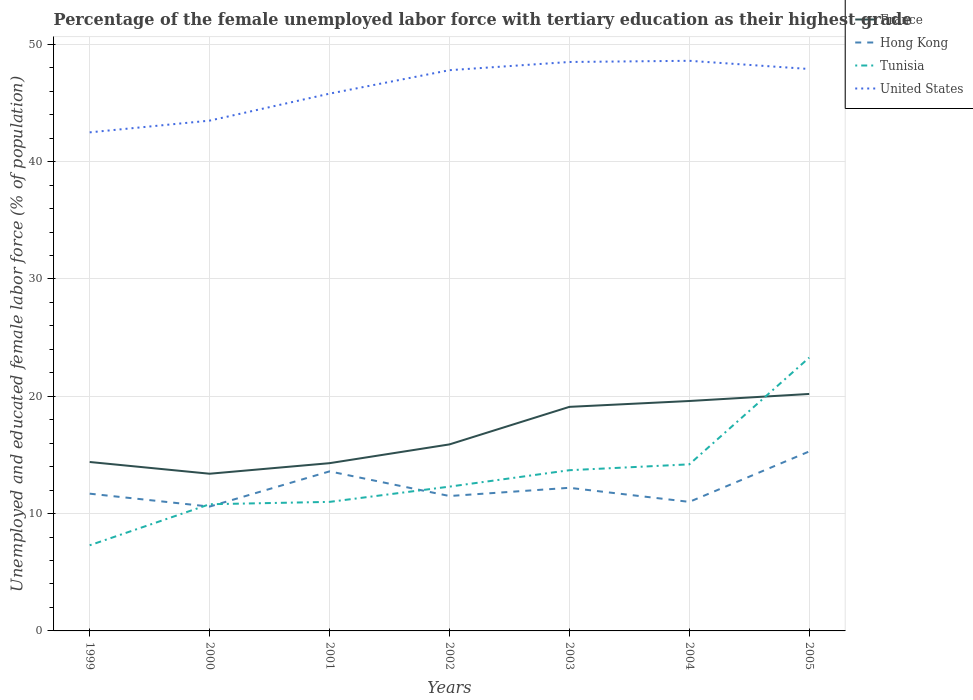How many different coloured lines are there?
Provide a succinct answer. 4. Across all years, what is the maximum percentage of the unemployed female labor force with tertiary education in Tunisia?
Your answer should be compact. 7.3. What is the total percentage of the unemployed female labor force with tertiary education in United States in the graph?
Your response must be concise. -5.1. What is the difference between the highest and the second highest percentage of the unemployed female labor force with tertiary education in Hong Kong?
Give a very brief answer. 4.7. Is the percentage of the unemployed female labor force with tertiary education in Hong Kong strictly greater than the percentage of the unemployed female labor force with tertiary education in Tunisia over the years?
Your answer should be compact. No. How many lines are there?
Offer a very short reply. 4. How many years are there in the graph?
Your response must be concise. 7. Are the values on the major ticks of Y-axis written in scientific E-notation?
Offer a terse response. No. What is the title of the graph?
Your response must be concise. Percentage of the female unemployed labor force with tertiary education as their highest grade. What is the label or title of the X-axis?
Keep it short and to the point. Years. What is the label or title of the Y-axis?
Give a very brief answer. Unemployed and educated female labor force (% of population). What is the Unemployed and educated female labor force (% of population) of France in 1999?
Offer a terse response. 14.4. What is the Unemployed and educated female labor force (% of population) in Hong Kong in 1999?
Your answer should be very brief. 11.7. What is the Unemployed and educated female labor force (% of population) of Tunisia in 1999?
Offer a terse response. 7.3. What is the Unemployed and educated female labor force (% of population) in United States in 1999?
Give a very brief answer. 42.5. What is the Unemployed and educated female labor force (% of population) in France in 2000?
Your response must be concise. 13.4. What is the Unemployed and educated female labor force (% of population) of Hong Kong in 2000?
Keep it short and to the point. 10.6. What is the Unemployed and educated female labor force (% of population) of Tunisia in 2000?
Provide a short and direct response. 10.8. What is the Unemployed and educated female labor force (% of population) in United States in 2000?
Provide a succinct answer. 43.5. What is the Unemployed and educated female labor force (% of population) of France in 2001?
Your response must be concise. 14.3. What is the Unemployed and educated female labor force (% of population) in Hong Kong in 2001?
Give a very brief answer. 13.6. What is the Unemployed and educated female labor force (% of population) in Tunisia in 2001?
Provide a short and direct response. 11. What is the Unemployed and educated female labor force (% of population) in United States in 2001?
Your response must be concise. 45.8. What is the Unemployed and educated female labor force (% of population) in France in 2002?
Offer a very short reply. 15.9. What is the Unemployed and educated female labor force (% of population) of Hong Kong in 2002?
Make the answer very short. 11.5. What is the Unemployed and educated female labor force (% of population) of Tunisia in 2002?
Offer a terse response. 12.3. What is the Unemployed and educated female labor force (% of population) of United States in 2002?
Offer a terse response. 47.8. What is the Unemployed and educated female labor force (% of population) of France in 2003?
Your response must be concise. 19.1. What is the Unemployed and educated female labor force (% of population) in Hong Kong in 2003?
Ensure brevity in your answer.  12.2. What is the Unemployed and educated female labor force (% of population) of Tunisia in 2003?
Keep it short and to the point. 13.7. What is the Unemployed and educated female labor force (% of population) in United States in 2003?
Offer a terse response. 48.5. What is the Unemployed and educated female labor force (% of population) of France in 2004?
Provide a short and direct response. 19.6. What is the Unemployed and educated female labor force (% of population) in Tunisia in 2004?
Provide a succinct answer. 14.2. What is the Unemployed and educated female labor force (% of population) of United States in 2004?
Ensure brevity in your answer.  48.6. What is the Unemployed and educated female labor force (% of population) in France in 2005?
Provide a short and direct response. 20.2. What is the Unemployed and educated female labor force (% of population) of Hong Kong in 2005?
Your answer should be very brief. 15.3. What is the Unemployed and educated female labor force (% of population) of Tunisia in 2005?
Make the answer very short. 23.3. What is the Unemployed and educated female labor force (% of population) in United States in 2005?
Offer a terse response. 47.9. Across all years, what is the maximum Unemployed and educated female labor force (% of population) in France?
Your answer should be compact. 20.2. Across all years, what is the maximum Unemployed and educated female labor force (% of population) of Hong Kong?
Provide a succinct answer. 15.3. Across all years, what is the maximum Unemployed and educated female labor force (% of population) in Tunisia?
Ensure brevity in your answer.  23.3. Across all years, what is the maximum Unemployed and educated female labor force (% of population) in United States?
Your response must be concise. 48.6. Across all years, what is the minimum Unemployed and educated female labor force (% of population) of France?
Your answer should be compact. 13.4. Across all years, what is the minimum Unemployed and educated female labor force (% of population) of Hong Kong?
Offer a very short reply. 10.6. Across all years, what is the minimum Unemployed and educated female labor force (% of population) in Tunisia?
Ensure brevity in your answer.  7.3. Across all years, what is the minimum Unemployed and educated female labor force (% of population) of United States?
Your response must be concise. 42.5. What is the total Unemployed and educated female labor force (% of population) in France in the graph?
Keep it short and to the point. 116.9. What is the total Unemployed and educated female labor force (% of population) of Hong Kong in the graph?
Make the answer very short. 85.9. What is the total Unemployed and educated female labor force (% of population) of Tunisia in the graph?
Make the answer very short. 92.6. What is the total Unemployed and educated female labor force (% of population) in United States in the graph?
Offer a terse response. 324.6. What is the difference between the Unemployed and educated female labor force (% of population) in France in 1999 and that in 2000?
Give a very brief answer. 1. What is the difference between the Unemployed and educated female labor force (% of population) of Hong Kong in 1999 and that in 2000?
Your answer should be very brief. 1.1. What is the difference between the Unemployed and educated female labor force (% of population) in Hong Kong in 1999 and that in 2001?
Offer a very short reply. -1.9. What is the difference between the Unemployed and educated female labor force (% of population) of Hong Kong in 1999 and that in 2002?
Offer a terse response. 0.2. What is the difference between the Unemployed and educated female labor force (% of population) of United States in 1999 and that in 2002?
Your answer should be very brief. -5.3. What is the difference between the Unemployed and educated female labor force (% of population) of France in 1999 and that in 2003?
Provide a succinct answer. -4.7. What is the difference between the Unemployed and educated female labor force (% of population) of United States in 1999 and that in 2003?
Offer a terse response. -6. What is the difference between the Unemployed and educated female labor force (% of population) of Hong Kong in 1999 and that in 2004?
Provide a succinct answer. 0.7. What is the difference between the Unemployed and educated female labor force (% of population) of United States in 1999 and that in 2004?
Your response must be concise. -6.1. What is the difference between the Unemployed and educated female labor force (% of population) of France in 1999 and that in 2005?
Your answer should be very brief. -5.8. What is the difference between the Unemployed and educated female labor force (% of population) in Tunisia in 2000 and that in 2001?
Offer a terse response. -0.2. What is the difference between the Unemployed and educated female labor force (% of population) in Tunisia in 2000 and that in 2002?
Give a very brief answer. -1.5. What is the difference between the Unemployed and educated female labor force (% of population) in United States in 2000 and that in 2002?
Give a very brief answer. -4.3. What is the difference between the Unemployed and educated female labor force (% of population) in France in 2000 and that in 2004?
Ensure brevity in your answer.  -6.2. What is the difference between the Unemployed and educated female labor force (% of population) in Hong Kong in 2000 and that in 2004?
Your answer should be very brief. -0.4. What is the difference between the Unemployed and educated female labor force (% of population) of United States in 2000 and that in 2004?
Your response must be concise. -5.1. What is the difference between the Unemployed and educated female labor force (% of population) of Hong Kong in 2000 and that in 2005?
Offer a terse response. -4.7. What is the difference between the Unemployed and educated female labor force (% of population) in France in 2001 and that in 2002?
Your answer should be compact. -1.6. What is the difference between the Unemployed and educated female labor force (% of population) in Hong Kong in 2001 and that in 2002?
Make the answer very short. 2.1. What is the difference between the Unemployed and educated female labor force (% of population) in Tunisia in 2001 and that in 2002?
Keep it short and to the point. -1.3. What is the difference between the Unemployed and educated female labor force (% of population) in France in 2001 and that in 2003?
Offer a terse response. -4.8. What is the difference between the Unemployed and educated female labor force (% of population) in Hong Kong in 2001 and that in 2003?
Keep it short and to the point. 1.4. What is the difference between the Unemployed and educated female labor force (% of population) of Hong Kong in 2001 and that in 2004?
Provide a succinct answer. 2.6. What is the difference between the Unemployed and educated female labor force (% of population) of Tunisia in 2001 and that in 2005?
Your answer should be very brief. -12.3. What is the difference between the Unemployed and educated female labor force (% of population) of United States in 2001 and that in 2005?
Your response must be concise. -2.1. What is the difference between the Unemployed and educated female labor force (% of population) of France in 2002 and that in 2003?
Ensure brevity in your answer.  -3.2. What is the difference between the Unemployed and educated female labor force (% of population) of Tunisia in 2002 and that in 2003?
Offer a terse response. -1.4. What is the difference between the Unemployed and educated female labor force (% of population) of United States in 2002 and that in 2003?
Keep it short and to the point. -0.7. What is the difference between the Unemployed and educated female labor force (% of population) of France in 2002 and that in 2004?
Your answer should be compact. -3.7. What is the difference between the Unemployed and educated female labor force (% of population) in Hong Kong in 2002 and that in 2004?
Offer a terse response. 0.5. What is the difference between the Unemployed and educated female labor force (% of population) in Tunisia in 2002 and that in 2004?
Your response must be concise. -1.9. What is the difference between the Unemployed and educated female labor force (% of population) in Tunisia in 2002 and that in 2005?
Give a very brief answer. -11. What is the difference between the Unemployed and educated female labor force (% of population) in France in 2003 and that in 2004?
Make the answer very short. -0.5. What is the difference between the Unemployed and educated female labor force (% of population) in Hong Kong in 2003 and that in 2004?
Offer a terse response. 1.2. What is the difference between the Unemployed and educated female labor force (% of population) of Tunisia in 2003 and that in 2004?
Give a very brief answer. -0.5. What is the difference between the Unemployed and educated female labor force (% of population) of France in 2003 and that in 2005?
Make the answer very short. -1.1. What is the difference between the Unemployed and educated female labor force (% of population) of Tunisia in 2003 and that in 2005?
Make the answer very short. -9.6. What is the difference between the Unemployed and educated female labor force (% of population) in France in 2004 and that in 2005?
Your response must be concise. -0.6. What is the difference between the Unemployed and educated female labor force (% of population) of France in 1999 and the Unemployed and educated female labor force (% of population) of United States in 2000?
Give a very brief answer. -29.1. What is the difference between the Unemployed and educated female labor force (% of population) in Hong Kong in 1999 and the Unemployed and educated female labor force (% of population) in Tunisia in 2000?
Your answer should be compact. 0.9. What is the difference between the Unemployed and educated female labor force (% of population) in Hong Kong in 1999 and the Unemployed and educated female labor force (% of population) in United States in 2000?
Your answer should be very brief. -31.8. What is the difference between the Unemployed and educated female labor force (% of population) of Tunisia in 1999 and the Unemployed and educated female labor force (% of population) of United States in 2000?
Provide a succinct answer. -36.2. What is the difference between the Unemployed and educated female labor force (% of population) of France in 1999 and the Unemployed and educated female labor force (% of population) of Hong Kong in 2001?
Your answer should be compact. 0.8. What is the difference between the Unemployed and educated female labor force (% of population) of France in 1999 and the Unemployed and educated female labor force (% of population) of United States in 2001?
Your response must be concise. -31.4. What is the difference between the Unemployed and educated female labor force (% of population) in Hong Kong in 1999 and the Unemployed and educated female labor force (% of population) in Tunisia in 2001?
Offer a very short reply. 0.7. What is the difference between the Unemployed and educated female labor force (% of population) in Hong Kong in 1999 and the Unemployed and educated female labor force (% of population) in United States in 2001?
Offer a terse response. -34.1. What is the difference between the Unemployed and educated female labor force (% of population) in Tunisia in 1999 and the Unemployed and educated female labor force (% of population) in United States in 2001?
Ensure brevity in your answer.  -38.5. What is the difference between the Unemployed and educated female labor force (% of population) of France in 1999 and the Unemployed and educated female labor force (% of population) of Hong Kong in 2002?
Your answer should be compact. 2.9. What is the difference between the Unemployed and educated female labor force (% of population) of France in 1999 and the Unemployed and educated female labor force (% of population) of Tunisia in 2002?
Make the answer very short. 2.1. What is the difference between the Unemployed and educated female labor force (% of population) in France in 1999 and the Unemployed and educated female labor force (% of population) in United States in 2002?
Offer a terse response. -33.4. What is the difference between the Unemployed and educated female labor force (% of population) of Hong Kong in 1999 and the Unemployed and educated female labor force (% of population) of Tunisia in 2002?
Offer a terse response. -0.6. What is the difference between the Unemployed and educated female labor force (% of population) in Hong Kong in 1999 and the Unemployed and educated female labor force (% of population) in United States in 2002?
Ensure brevity in your answer.  -36.1. What is the difference between the Unemployed and educated female labor force (% of population) of Tunisia in 1999 and the Unemployed and educated female labor force (% of population) of United States in 2002?
Provide a short and direct response. -40.5. What is the difference between the Unemployed and educated female labor force (% of population) of France in 1999 and the Unemployed and educated female labor force (% of population) of Hong Kong in 2003?
Your answer should be compact. 2.2. What is the difference between the Unemployed and educated female labor force (% of population) of France in 1999 and the Unemployed and educated female labor force (% of population) of United States in 2003?
Offer a terse response. -34.1. What is the difference between the Unemployed and educated female labor force (% of population) of Hong Kong in 1999 and the Unemployed and educated female labor force (% of population) of Tunisia in 2003?
Give a very brief answer. -2. What is the difference between the Unemployed and educated female labor force (% of population) of Hong Kong in 1999 and the Unemployed and educated female labor force (% of population) of United States in 2003?
Offer a terse response. -36.8. What is the difference between the Unemployed and educated female labor force (% of population) in Tunisia in 1999 and the Unemployed and educated female labor force (% of population) in United States in 2003?
Offer a very short reply. -41.2. What is the difference between the Unemployed and educated female labor force (% of population) of France in 1999 and the Unemployed and educated female labor force (% of population) of Tunisia in 2004?
Give a very brief answer. 0.2. What is the difference between the Unemployed and educated female labor force (% of population) of France in 1999 and the Unemployed and educated female labor force (% of population) of United States in 2004?
Make the answer very short. -34.2. What is the difference between the Unemployed and educated female labor force (% of population) of Hong Kong in 1999 and the Unemployed and educated female labor force (% of population) of United States in 2004?
Provide a short and direct response. -36.9. What is the difference between the Unemployed and educated female labor force (% of population) of Tunisia in 1999 and the Unemployed and educated female labor force (% of population) of United States in 2004?
Your response must be concise. -41.3. What is the difference between the Unemployed and educated female labor force (% of population) of France in 1999 and the Unemployed and educated female labor force (% of population) of Hong Kong in 2005?
Offer a very short reply. -0.9. What is the difference between the Unemployed and educated female labor force (% of population) in France in 1999 and the Unemployed and educated female labor force (% of population) in United States in 2005?
Keep it short and to the point. -33.5. What is the difference between the Unemployed and educated female labor force (% of population) of Hong Kong in 1999 and the Unemployed and educated female labor force (% of population) of Tunisia in 2005?
Your answer should be compact. -11.6. What is the difference between the Unemployed and educated female labor force (% of population) of Hong Kong in 1999 and the Unemployed and educated female labor force (% of population) of United States in 2005?
Offer a terse response. -36.2. What is the difference between the Unemployed and educated female labor force (% of population) of Tunisia in 1999 and the Unemployed and educated female labor force (% of population) of United States in 2005?
Offer a terse response. -40.6. What is the difference between the Unemployed and educated female labor force (% of population) of France in 2000 and the Unemployed and educated female labor force (% of population) of United States in 2001?
Keep it short and to the point. -32.4. What is the difference between the Unemployed and educated female labor force (% of population) of Hong Kong in 2000 and the Unemployed and educated female labor force (% of population) of Tunisia in 2001?
Provide a short and direct response. -0.4. What is the difference between the Unemployed and educated female labor force (% of population) in Hong Kong in 2000 and the Unemployed and educated female labor force (% of population) in United States in 2001?
Ensure brevity in your answer.  -35.2. What is the difference between the Unemployed and educated female labor force (% of population) of Tunisia in 2000 and the Unemployed and educated female labor force (% of population) of United States in 2001?
Give a very brief answer. -35. What is the difference between the Unemployed and educated female labor force (% of population) in France in 2000 and the Unemployed and educated female labor force (% of population) in Hong Kong in 2002?
Offer a terse response. 1.9. What is the difference between the Unemployed and educated female labor force (% of population) in France in 2000 and the Unemployed and educated female labor force (% of population) in United States in 2002?
Your response must be concise. -34.4. What is the difference between the Unemployed and educated female labor force (% of population) in Hong Kong in 2000 and the Unemployed and educated female labor force (% of population) in United States in 2002?
Your response must be concise. -37.2. What is the difference between the Unemployed and educated female labor force (% of population) of Tunisia in 2000 and the Unemployed and educated female labor force (% of population) of United States in 2002?
Your answer should be very brief. -37. What is the difference between the Unemployed and educated female labor force (% of population) of France in 2000 and the Unemployed and educated female labor force (% of population) of Hong Kong in 2003?
Offer a very short reply. 1.2. What is the difference between the Unemployed and educated female labor force (% of population) in France in 2000 and the Unemployed and educated female labor force (% of population) in Tunisia in 2003?
Offer a terse response. -0.3. What is the difference between the Unemployed and educated female labor force (% of population) in France in 2000 and the Unemployed and educated female labor force (% of population) in United States in 2003?
Keep it short and to the point. -35.1. What is the difference between the Unemployed and educated female labor force (% of population) of Hong Kong in 2000 and the Unemployed and educated female labor force (% of population) of Tunisia in 2003?
Offer a terse response. -3.1. What is the difference between the Unemployed and educated female labor force (% of population) of Hong Kong in 2000 and the Unemployed and educated female labor force (% of population) of United States in 2003?
Your answer should be very brief. -37.9. What is the difference between the Unemployed and educated female labor force (% of population) in Tunisia in 2000 and the Unemployed and educated female labor force (% of population) in United States in 2003?
Offer a terse response. -37.7. What is the difference between the Unemployed and educated female labor force (% of population) of France in 2000 and the Unemployed and educated female labor force (% of population) of Hong Kong in 2004?
Ensure brevity in your answer.  2.4. What is the difference between the Unemployed and educated female labor force (% of population) in France in 2000 and the Unemployed and educated female labor force (% of population) in Tunisia in 2004?
Offer a very short reply. -0.8. What is the difference between the Unemployed and educated female labor force (% of population) of France in 2000 and the Unemployed and educated female labor force (% of population) of United States in 2004?
Your response must be concise. -35.2. What is the difference between the Unemployed and educated female labor force (% of population) of Hong Kong in 2000 and the Unemployed and educated female labor force (% of population) of Tunisia in 2004?
Provide a succinct answer. -3.6. What is the difference between the Unemployed and educated female labor force (% of population) in Hong Kong in 2000 and the Unemployed and educated female labor force (% of population) in United States in 2004?
Give a very brief answer. -38. What is the difference between the Unemployed and educated female labor force (% of population) of Tunisia in 2000 and the Unemployed and educated female labor force (% of population) of United States in 2004?
Provide a short and direct response. -37.8. What is the difference between the Unemployed and educated female labor force (% of population) in France in 2000 and the Unemployed and educated female labor force (% of population) in United States in 2005?
Make the answer very short. -34.5. What is the difference between the Unemployed and educated female labor force (% of population) in Hong Kong in 2000 and the Unemployed and educated female labor force (% of population) in Tunisia in 2005?
Offer a very short reply. -12.7. What is the difference between the Unemployed and educated female labor force (% of population) of Hong Kong in 2000 and the Unemployed and educated female labor force (% of population) of United States in 2005?
Offer a very short reply. -37.3. What is the difference between the Unemployed and educated female labor force (% of population) in Tunisia in 2000 and the Unemployed and educated female labor force (% of population) in United States in 2005?
Provide a short and direct response. -37.1. What is the difference between the Unemployed and educated female labor force (% of population) in France in 2001 and the Unemployed and educated female labor force (% of population) in Tunisia in 2002?
Your response must be concise. 2. What is the difference between the Unemployed and educated female labor force (% of population) of France in 2001 and the Unemployed and educated female labor force (% of population) of United States in 2002?
Offer a terse response. -33.5. What is the difference between the Unemployed and educated female labor force (% of population) of Hong Kong in 2001 and the Unemployed and educated female labor force (% of population) of Tunisia in 2002?
Offer a terse response. 1.3. What is the difference between the Unemployed and educated female labor force (% of population) in Hong Kong in 2001 and the Unemployed and educated female labor force (% of population) in United States in 2002?
Give a very brief answer. -34.2. What is the difference between the Unemployed and educated female labor force (% of population) in Tunisia in 2001 and the Unemployed and educated female labor force (% of population) in United States in 2002?
Your answer should be compact. -36.8. What is the difference between the Unemployed and educated female labor force (% of population) in France in 2001 and the Unemployed and educated female labor force (% of population) in Hong Kong in 2003?
Your answer should be very brief. 2.1. What is the difference between the Unemployed and educated female labor force (% of population) in France in 2001 and the Unemployed and educated female labor force (% of population) in Tunisia in 2003?
Offer a terse response. 0.6. What is the difference between the Unemployed and educated female labor force (% of population) of France in 2001 and the Unemployed and educated female labor force (% of population) of United States in 2003?
Offer a terse response. -34.2. What is the difference between the Unemployed and educated female labor force (% of population) of Hong Kong in 2001 and the Unemployed and educated female labor force (% of population) of United States in 2003?
Make the answer very short. -34.9. What is the difference between the Unemployed and educated female labor force (% of population) in Tunisia in 2001 and the Unemployed and educated female labor force (% of population) in United States in 2003?
Your response must be concise. -37.5. What is the difference between the Unemployed and educated female labor force (% of population) in France in 2001 and the Unemployed and educated female labor force (% of population) in Hong Kong in 2004?
Give a very brief answer. 3.3. What is the difference between the Unemployed and educated female labor force (% of population) of France in 2001 and the Unemployed and educated female labor force (% of population) of United States in 2004?
Provide a succinct answer. -34.3. What is the difference between the Unemployed and educated female labor force (% of population) of Hong Kong in 2001 and the Unemployed and educated female labor force (% of population) of United States in 2004?
Your answer should be compact. -35. What is the difference between the Unemployed and educated female labor force (% of population) of Tunisia in 2001 and the Unemployed and educated female labor force (% of population) of United States in 2004?
Provide a succinct answer. -37.6. What is the difference between the Unemployed and educated female labor force (% of population) of France in 2001 and the Unemployed and educated female labor force (% of population) of Hong Kong in 2005?
Provide a short and direct response. -1. What is the difference between the Unemployed and educated female labor force (% of population) of France in 2001 and the Unemployed and educated female labor force (% of population) of United States in 2005?
Offer a very short reply. -33.6. What is the difference between the Unemployed and educated female labor force (% of population) in Hong Kong in 2001 and the Unemployed and educated female labor force (% of population) in Tunisia in 2005?
Your answer should be very brief. -9.7. What is the difference between the Unemployed and educated female labor force (% of population) in Hong Kong in 2001 and the Unemployed and educated female labor force (% of population) in United States in 2005?
Keep it short and to the point. -34.3. What is the difference between the Unemployed and educated female labor force (% of population) of Tunisia in 2001 and the Unemployed and educated female labor force (% of population) of United States in 2005?
Make the answer very short. -36.9. What is the difference between the Unemployed and educated female labor force (% of population) in France in 2002 and the Unemployed and educated female labor force (% of population) in Hong Kong in 2003?
Offer a very short reply. 3.7. What is the difference between the Unemployed and educated female labor force (% of population) in France in 2002 and the Unemployed and educated female labor force (% of population) in United States in 2003?
Give a very brief answer. -32.6. What is the difference between the Unemployed and educated female labor force (% of population) of Hong Kong in 2002 and the Unemployed and educated female labor force (% of population) of Tunisia in 2003?
Keep it short and to the point. -2.2. What is the difference between the Unemployed and educated female labor force (% of population) of Hong Kong in 2002 and the Unemployed and educated female labor force (% of population) of United States in 2003?
Make the answer very short. -37. What is the difference between the Unemployed and educated female labor force (% of population) in Tunisia in 2002 and the Unemployed and educated female labor force (% of population) in United States in 2003?
Provide a short and direct response. -36.2. What is the difference between the Unemployed and educated female labor force (% of population) in France in 2002 and the Unemployed and educated female labor force (% of population) in Hong Kong in 2004?
Keep it short and to the point. 4.9. What is the difference between the Unemployed and educated female labor force (% of population) of France in 2002 and the Unemployed and educated female labor force (% of population) of United States in 2004?
Offer a very short reply. -32.7. What is the difference between the Unemployed and educated female labor force (% of population) in Hong Kong in 2002 and the Unemployed and educated female labor force (% of population) in Tunisia in 2004?
Keep it short and to the point. -2.7. What is the difference between the Unemployed and educated female labor force (% of population) in Hong Kong in 2002 and the Unemployed and educated female labor force (% of population) in United States in 2004?
Your answer should be compact. -37.1. What is the difference between the Unemployed and educated female labor force (% of population) of Tunisia in 2002 and the Unemployed and educated female labor force (% of population) of United States in 2004?
Your response must be concise. -36.3. What is the difference between the Unemployed and educated female labor force (% of population) of France in 2002 and the Unemployed and educated female labor force (% of population) of Tunisia in 2005?
Your answer should be compact. -7.4. What is the difference between the Unemployed and educated female labor force (% of population) of France in 2002 and the Unemployed and educated female labor force (% of population) of United States in 2005?
Give a very brief answer. -32. What is the difference between the Unemployed and educated female labor force (% of population) of Hong Kong in 2002 and the Unemployed and educated female labor force (% of population) of Tunisia in 2005?
Your answer should be very brief. -11.8. What is the difference between the Unemployed and educated female labor force (% of population) in Hong Kong in 2002 and the Unemployed and educated female labor force (% of population) in United States in 2005?
Give a very brief answer. -36.4. What is the difference between the Unemployed and educated female labor force (% of population) in Tunisia in 2002 and the Unemployed and educated female labor force (% of population) in United States in 2005?
Offer a terse response. -35.6. What is the difference between the Unemployed and educated female labor force (% of population) in France in 2003 and the Unemployed and educated female labor force (% of population) in United States in 2004?
Give a very brief answer. -29.5. What is the difference between the Unemployed and educated female labor force (% of population) in Hong Kong in 2003 and the Unemployed and educated female labor force (% of population) in United States in 2004?
Your response must be concise. -36.4. What is the difference between the Unemployed and educated female labor force (% of population) in Tunisia in 2003 and the Unemployed and educated female labor force (% of population) in United States in 2004?
Ensure brevity in your answer.  -34.9. What is the difference between the Unemployed and educated female labor force (% of population) of France in 2003 and the Unemployed and educated female labor force (% of population) of Hong Kong in 2005?
Provide a succinct answer. 3.8. What is the difference between the Unemployed and educated female labor force (% of population) in France in 2003 and the Unemployed and educated female labor force (% of population) in Tunisia in 2005?
Your answer should be very brief. -4.2. What is the difference between the Unemployed and educated female labor force (% of population) of France in 2003 and the Unemployed and educated female labor force (% of population) of United States in 2005?
Provide a succinct answer. -28.8. What is the difference between the Unemployed and educated female labor force (% of population) of Hong Kong in 2003 and the Unemployed and educated female labor force (% of population) of Tunisia in 2005?
Your answer should be compact. -11.1. What is the difference between the Unemployed and educated female labor force (% of population) of Hong Kong in 2003 and the Unemployed and educated female labor force (% of population) of United States in 2005?
Ensure brevity in your answer.  -35.7. What is the difference between the Unemployed and educated female labor force (% of population) of Tunisia in 2003 and the Unemployed and educated female labor force (% of population) of United States in 2005?
Offer a very short reply. -34.2. What is the difference between the Unemployed and educated female labor force (% of population) in France in 2004 and the Unemployed and educated female labor force (% of population) in United States in 2005?
Provide a short and direct response. -28.3. What is the difference between the Unemployed and educated female labor force (% of population) in Hong Kong in 2004 and the Unemployed and educated female labor force (% of population) in Tunisia in 2005?
Make the answer very short. -12.3. What is the difference between the Unemployed and educated female labor force (% of population) of Hong Kong in 2004 and the Unemployed and educated female labor force (% of population) of United States in 2005?
Your answer should be very brief. -36.9. What is the difference between the Unemployed and educated female labor force (% of population) in Tunisia in 2004 and the Unemployed and educated female labor force (% of population) in United States in 2005?
Provide a succinct answer. -33.7. What is the average Unemployed and educated female labor force (% of population) in Hong Kong per year?
Offer a terse response. 12.27. What is the average Unemployed and educated female labor force (% of population) of Tunisia per year?
Your answer should be very brief. 13.23. What is the average Unemployed and educated female labor force (% of population) in United States per year?
Provide a short and direct response. 46.37. In the year 1999, what is the difference between the Unemployed and educated female labor force (% of population) of France and Unemployed and educated female labor force (% of population) of United States?
Your answer should be compact. -28.1. In the year 1999, what is the difference between the Unemployed and educated female labor force (% of population) of Hong Kong and Unemployed and educated female labor force (% of population) of Tunisia?
Offer a very short reply. 4.4. In the year 1999, what is the difference between the Unemployed and educated female labor force (% of population) in Hong Kong and Unemployed and educated female labor force (% of population) in United States?
Keep it short and to the point. -30.8. In the year 1999, what is the difference between the Unemployed and educated female labor force (% of population) of Tunisia and Unemployed and educated female labor force (% of population) of United States?
Make the answer very short. -35.2. In the year 2000, what is the difference between the Unemployed and educated female labor force (% of population) of France and Unemployed and educated female labor force (% of population) of United States?
Your answer should be very brief. -30.1. In the year 2000, what is the difference between the Unemployed and educated female labor force (% of population) in Hong Kong and Unemployed and educated female labor force (% of population) in Tunisia?
Ensure brevity in your answer.  -0.2. In the year 2000, what is the difference between the Unemployed and educated female labor force (% of population) of Hong Kong and Unemployed and educated female labor force (% of population) of United States?
Keep it short and to the point. -32.9. In the year 2000, what is the difference between the Unemployed and educated female labor force (% of population) of Tunisia and Unemployed and educated female labor force (% of population) of United States?
Offer a terse response. -32.7. In the year 2001, what is the difference between the Unemployed and educated female labor force (% of population) in France and Unemployed and educated female labor force (% of population) in Tunisia?
Give a very brief answer. 3.3. In the year 2001, what is the difference between the Unemployed and educated female labor force (% of population) of France and Unemployed and educated female labor force (% of population) of United States?
Keep it short and to the point. -31.5. In the year 2001, what is the difference between the Unemployed and educated female labor force (% of population) in Hong Kong and Unemployed and educated female labor force (% of population) in United States?
Offer a very short reply. -32.2. In the year 2001, what is the difference between the Unemployed and educated female labor force (% of population) in Tunisia and Unemployed and educated female labor force (% of population) in United States?
Your response must be concise. -34.8. In the year 2002, what is the difference between the Unemployed and educated female labor force (% of population) in France and Unemployed and educated female labor force (% of population) in Hong Kong?
Give a very brief answer. 4.4. In the year 2002, what is the difference between the Unemployed and educated female labor force (% of population) of France and Unemployed and educated female labor force (% of population) of Tunisia?
Give a very brief answer. 3.6. In the year 2002, what is the difference between the Unemployed and educated female labor force (% of population) of France and Unemployed and educated female labor force (% of population) of United States?
Offer a terse response. -31.9. In the year 2002, what is the difference between the Unemployed and educated female labor force (% of population) of Hong Kong and Unemployed and educated female labor force (% of population) of Tunisia?
Keep it short and to the point. -0.8. In the year 2002, what is the difference between the Unemployed and educated female labor force (% of population) of Hong Kong and Unemployed and educated female labor force (% of population) of United States?
Make the answer very short. -36.3. In the year 2002, what is the difference between the Unemployed and educated female labor force (% of population) in Tunisia and Unemployed and educated female labor force (% of population) in United States?
Provide a succinct answer. -35.5. In the year 2003, what is the difference between the Unemployed and educated female labor force (% of population) in France and Unemployed and educated female labor force (% of population) in Tunisia?
Provide a succinct answer. 5.4. In the year 2003, what is the difference between the Unemployed and educated female labor force (% of population) of France and Unemployed and educated female labor force (% of population) of United States?
Give a very brief answer. -29.4. In the year 2003, what is the difference between the Unemployed and educated female labor force (% of population) in Hong Kong and Unemployed and educated female labor force (% of population) in Tunisia?
Provide a short and direct response. -1.5. In the year 2003, what is the difference between the Unemployed and educated female labor force (% of population) of Hong Kong and Unemployed and educated female labor force (% of population) of United States?
Your response must be concise. -36.3. In the year 2003, what is the difference between the Unemployed and educated female labor force (% of population) of Tunisia and Unemployed and educated female labor force (% of population) of United States?
Give a very brief answer. -34.8. In the year 2004, what is the difference between the Unemployed and educated female labor force (% of population) in France and Unemployed and educated female labor force (% of population) in Hong Kong?
Offer a very short reply. 8.6. In the year 2004, what is the difference between the Unemployed and educated female labor force (% of population) of Hong Kong and Unemployed and educated female labor force (% of population) of United States?
Your answer should be very brief. -37.6. In the year 2004, what is the difference between the Unemployed and educated female labor force (% of population) in Tunisia and Unemployed and educated female labor force (% of population) in United States?
Offer a terse response. -34.4. In the year 2005, what is the difference between the Unemployed and educated female labor force (% of population) in France and Unemployed and educated female labor force (% of population) in United States?
Keep it short and to the point. -27.7. In the year 2005, what is the difference between the Unemployed and educated female labor force (% of population) in Hong Kong and Unemployed and educated female labor force (% of population) in United States?
Provide a succinct answer. -32.6. In the year 2005, what is the difference between the Unemployed and educated female labor force (% of population) of Tunisia and Unemployed and educated female labor force (% of population) of United States?
Provide a succinct answer. -24.6. What is the ratio of the Unemployed and educated female labor force (% of population) in France in 1999 to that in 2000?
Your answer should be compact. 1.07. What is the ratio of the Unemployed and educated female labor force (% of population) of Hong Kong in 1999 to that in 2000?
Your answer should be very brief. 1.1. What is the ratio of the Unemployed and educated female labor force (% of population) in Tunisia in 1999 to that in 2000?
Offer a very short reply. 0.68. What is the ratio of the Unemployed and educated female labor force (% of population) in Hong Kong in 1999 to that in 2001?
Keep it short and to the point. 0.86. What is the ratio of the Unemployed and educated female labor force (% of population) of Tunisia in 1999 to that in 2001?
Offer a very short reply. 0.66. What is the ratio of the Unemployed and educated female labor force (% of population) of United States in 1999 to that in 2001?
Give a very brief answer. 0.93. What is the ratio of the Unemployed and educated female labor force (% of population) of France in 1999 to that in 2002?
Make the answer very short. 0.91. What is the ratio of the Unemployed and educated female labor force (% of population) of Hong Kong in 1999 to that in 2002?
Offer a terse response. 1.02. What is the ratio of the Unemployed and educated female labor force (% of population) of Tunisia in 1999 to that in 2002?
Give a very brief answer. 0.59. What is the ratio of the Unemployed and educated female labor force (% of population) in United States in 1999 to that in 2002?
Give a very brief answer. 0.89. What is the ratio of the Unemployed and educated female labor force (% of population) in France in 1999 to that in 2003?
Offer a terse response. 0.75. What is the ratio of the Unemployed and educated female labor force (% of population) of Hong Kong in 1999 to that in 2003?
Your answer should be very brief. 0.96. What is the ratio of the Unemployed and educated female labor force (% of population) in Tunisia in 1999 to that in 2003?
Offer a terse response. 0.53. What is the ratio of the Unemployed and educated female labor force (% of population) of United States in 1999 to that in 2003?
Offer a terse response. 0.88. What is the ratio of the Unemployed and educated female labor force (% of population) of France in 1999 to that in 2004?
Give a very brief answer. 0.73. What is the ratio of the Unemployed and educated female labor force (% of population) in Hong Kong in 1999 to that in 2004?
Keep it short and to the point. 1.06. What is the ratio of the Unemployed and educated female labor force (% of population) of Tunisia in 1999 to that in 2004?
Give a very brief answer. 0.51. What is the ratio of the Unemployed and educated female labor force (% of population) of United States in 1999 to that in 2004?
Provide a succinct answer. 0.87. What is the ratio of the Unemployed and educated female labor force (% of population) of France in 1999 to that in 2005?
Keep it short and to the point. 0.71. What is the ratio of the Unemployed and educated female labor force (% of population) of Hong Kong in 1999 to that in 2005?
Offer a terse response. 0.76. What is the ratio of the Unemployed and educated female labor force (% of population) in Tunisia in 1999 to that in 2005?
Offer a terse response. 0.31. What is the ratio of the Unemployed and educated female labor force (% of population) in United States in 1999 to that in 2005?
Offer a very short reply. 0.89. What is the ratio of the Unemployed and educated female labor force (% of population) in France in 2000 to that in 2001?
Give a very brief answer. 0.94. What is the ratio of the Unemployed and educated female labor force (% of population) of Hong Kong in 2000 to that in 2001?
Keep it short and to the point. 0.78. What is the ratio of the Unemployed and educated female labor force (% of population) of Tunisia in 2000 to that in 2001?
Keep it short and to the point. 0.98. What is the ratio of the Unemployed and educated female labor force (% of population) in United States in 2000 to that in 2001?
Keep it short and to the point. 0.95. What is the ratio of the Unemployed and educated female labor force (% of population) in France in 2000 to that in 2002?
Keep it short and to the point. 0.84. What is the ratio of the Unemployed and educated female labor force (% of population) of Hong Kong in 2000 to that in 2002?
Make the answer very short. 0.92. What is the ratio of the Unemployed and educated female labor force (% of population) in Tunisia in 2000 to that in 2002?
Give a very brief answer. 0.88. What is the ratio of the Unemployed and educated female labor force (% of population) in United States in 2000 to that in 2002?
Keep it short and to the point. 0.91. What is the ratio of the Unemployed and educated female labor force (% of population) of France in 2000 to that in 2003?
Your response must be concise. 0.7. What is the ratio of the Unemployed and educated female labor force (% of population) of Hong Kong in 2000 to that in 2003?
Your answer should be very brief. 0.87. What is the ratio of the Unemployed and educated female labor force (% of population) in Tunisia in 2000 to that in 2003?
Your response must be concise. 0.79. What is the ratio of the Unemployed and educated female labor force (% of population) in United States in 2000 to that in 2003?
Keep it short and to the point. 0.9. What is the ratio of the Unemployed and educated female labor force (% of population) of France in 2000 to that in 2004?
Ensure brevity in your answer.  0.68. What is the ratio of the Unemployed and educated female labor force (% of population) of Hong Kong in 2000 to that in 2004?
Provide a short and direct response. 0.96. What is the ratio of the Unemployed and educated female labor force (% of population) of Tunisia in 2000 to that in 2004?
Provide a succinct answer. 0.76. What is the ratio of the Unemployed and educated female labor force (% of population) of United States in 2000 to that in 2004?
Offer a terse response. 0.9. What is the ratio of the Unemployed and educated female labor force (% of population) in France in 2000 to that in 2005?
Give a very brief answer. 0.66. What is the ratio of the Unemployed and educated female labor force (% of population) in Hong Kong in 2000 to that in 2005?
Offer a very short reply. 0.69. What is the ratio of the Unemployed and educated female labor force (% of population) in Tunisia in 2000 to that in 2005?
Your answer should be very brief. 0.46. What is the ratio of the Unemployed and educated female labor force (% of population) of United States in 2000 to that in 2005?
Your response must be concise. 0.91. What is the ratio of the Unemployed and educated female labor force (% of population) of France in 2001 to that in 2002?
Your response must be concise. 0.9. What is the ratio of the Unemployed and educated female labor force (% of population) in Hong Kong in 2001 to that in 2002?
Offer a very short reply. 1.18. What is the ratio of the Unemployed and educated female labor force (% of population) of Tunisia in 2001 to that in 2002?
Offer a terse response. 0.89. What is the ratio of the Unemployed and educated female labor force (% of population) of United States in 2001 to that in 2002?
Provide a short and direct response. 0.96. What is the ratio of the Unemployed and educated female labor force (% of population) of France in 2001 to that in 2003?
Offer a terse response. 0.75. What is the ratio of the Unemployed and educated female labor force (% of population) in Hong Kong in 2001 to that in 2003?
Offer a very short reply. 1.11. What is the ratio of the Unemployed and educated female labor force (% of population) of Tunisia in 2001 to that in 2003?
Ensure brevity in your answer.  0.8. What is the ratio of the Unemployed and educated female labor force (% of population) in United States in 2001 to that in 2003?
Your answer should be compact. 0.94. What is the ratio of the Unemployed and educated female labor force (% of population) of France in 2001 to that in 2004?
Keep it short and to the point. 0.73. What is the ratio of the Unemployed and educated female labor force (% of population) in Hong Kong in 2001 to that in 2004?
Make the answer very short. 1.24. What is the ratio of the Unemployed and educated female labor force (% of population) of Tunisia in 2001 to that in 2004?
Keep it short and to the point. 0.77. What is the ratio of the Unemployed and educated female labor force (% of population) in United States in 2001 to that in 2004?
Your answer should be very brief. 0.94. What is the ratio of the Unemployed and educated female labor force (% of population) of France in 2001 to that in 2005?
Make the answer very short. 0.71. What is the ratio of the Unemployed and educated female labor force (% of population) in Hong Kong in 2001 to that in 2005?
Offer a terse response. 0.89. What is the ratio of the Unemployed and educated female labor force (% of population) of Tunisia in 2001 to that in 2005?
Offer a terse response. 0.47. What is the ratio of the Unemployed and educated female labor force (% of population) of United States in 2001 to that in 2005?
Provide a short and direct response. 0.96. What is the ratio of the Unemployed and educated female labor force (% of population) in France in 2002 to that in 2003?
Your answer should be compact. 0.83. What is the ratio of the Unemployed and educated female labor force (% of population) of Hong Kong in 2002 to that in 2003?
Provide a short and direct response. 0.94. What is the ratio of the Unemployed and educated female labor force (% of population) of Tunisia in 2002 to that in 2003?
Keep it short and to the point. 0.9. What is the ratio of the Unemployed and educated female labor force (% of population) of United States in 2002 to that in 2003?
Ensure brevity in your answer.  0.99. What is the ratio of the Unemployed and educated female labor force (% of population) of France in 2002 to that in 2004?
Your answer should be compact. 0.81. What is the ratio of the Unemployed and educated female labor force (% of population) of Hong Kong in 2002 to that in 2004?
Your answer should be very brief. 1.05. What is the ratio of the Unemployed and educated female labor force (% of population) of Tunisia in 2002 to that in 2004?
Ensure brevity in your answer.  0.87. What is the ratio of the Unemployed and educated female labor force (% of population) in United States in 2002 to that in 2004?
Make the answer very short. 0.98. What is the ratio of the Unemployed and educated female labor force (% of population) of France in 2002 to that in 2005?
Give a very brief answer. 0.79. What is the ratio of the Unemployed and educated female labor force (% of population) of Hong Kong in 2002 to that in 2005?
Make the answer very short. 0.75. What is the ratio of the Unemployed and educated female labor force (% of population) in Tunisia in 2002 to that in 2005?
Provide a succinct answer. 0.53. What is the ratio of the Unemployed and educated female labor force (% of population) in United States in 2002 to that in 2005?
Make the answer very short. 1. What is the ratio of the Unemployed and educated female labor force (% of population) in France in 2003 to that in 2004?
Provide a short and direct response. 0.97. What is the ratio of the Unemployed and educated female labor force (% of population) in Hong Kong in 2003 to that in 2004?
Your answer should be very brief. 1.11. What is the ratio of the Unemployed and educated female labor force (% of population) in Tunisia in 2003 to that in 2004?
Provide a short and direct response. 0.96. What is the ratio of the Unemployed and educated female labor force (% of population) in France in 2003 to that in 2005?
Offer a terse response. 0.95. What is the ratio of the Unemployed and educated female labor force (% of population) in Hong Kong in 2003 to that in 2005?
Your answer should be compact. 0.8. What is the ratio of the Unemployed and educated female labor force (% of population) in Tunisia in 2003 to that in 2005?
Your answer should be compact. 0.59. What is the ratio of the Unemployed and educated female labor force (% of population) in United States in 2003 to that in 2005?
Offer a terse response. 1.01. What is the ratio of the Unemployed and educated female labor force (% of population) in France in 2004 to that in 2005?
Your response must be concise. 0.97. What is the ratio of the Unemployed and educated female labor force (% of population) in Hong Kong in 2004 to that in 2005?
Provide a succinct answer. 0.72. What is the ratio of the Unemployed and educated female labor force (% of population) in Tunisia in 2004 to that in 2005?
Offer a very short reply. 0.61. What is the ratio of the Unemployed and educated female labor force (% of population) in United States in 2004 to that in 2005?
Your response must be concise. 1.01. What is the difference between the highest and the second highest Unemployed and educated female labor force (% of population) of United States?
Give a very brief answer. 0.1. What is the difference between the highest and the lowest Unemployed and educated female labor force (% of population) of France?
Provide a short and direct response. 6.8. What is the difference between the highest and the lowest Unemployed and educated female labor force (% of population) of Hong Kong?
Provide a short and direct response. 4.7. What is the difference between the highest and the lowest Unemployed and educated female labor force (% of population) in United States?
Give a very brief answer. 6.1. 